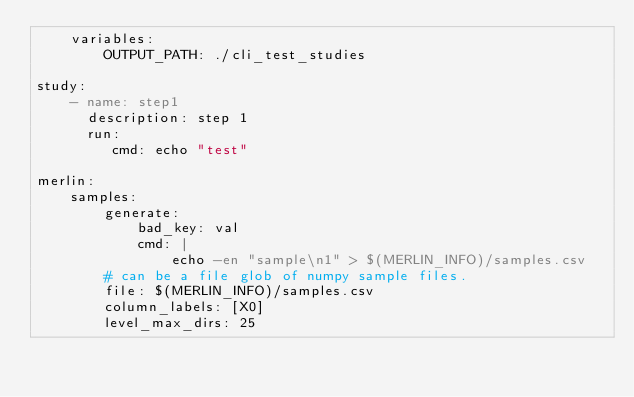<code> <loc_0><loc_0><loc_500><loc_500><_YAML_>    variables:
        OUTPUT_PATH: ./cli_test_studies

study:
    - name: step1 
      description: step 1
      run:
         cmd: echo "test"

merlin:
    samples:
        generate:
            bad_key: val
            cmd: |
                echo -en "sample\n1" > $(MERLIN_INFO)/samples.csv
        # can be a file glob of numpy sample files.
        file: $(MERLIN_INFO)/samples.csv
        column_labels: [X0]
        level_max_dirs: 25
</code> 